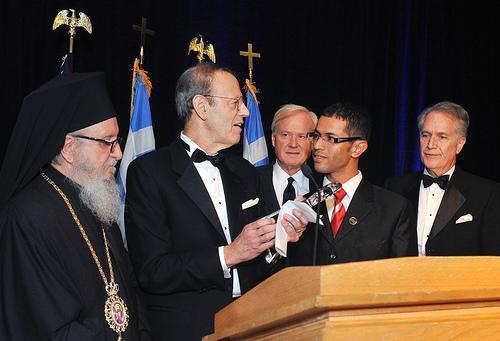How many flags are behind the men?
Give a very brief answer. 4. 